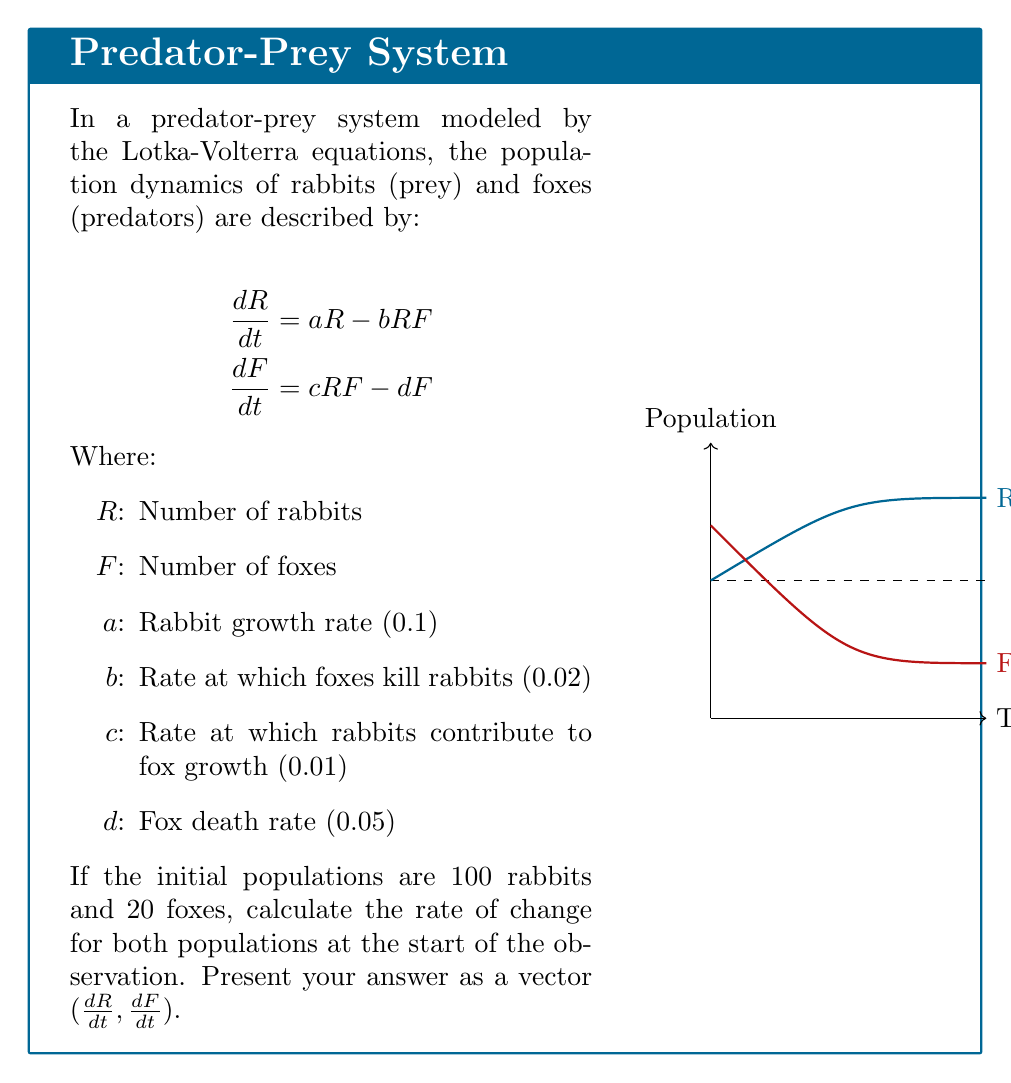Could you help me with this problem? To solve this problem, we'll follow these steps:

1) First, let's identify the given values:
   $R = 100$ (initial rabbit population)
   $F = 20$ (initial fox population)
   $a = 0.1$
   $b = 0.02$
   $c = 0.01$
   $d = 0.05$

2) Now, we'll calculate $dR/dt$ using the first equation:
   $$\frac{dR}{dt} = aR - bRF$$
   $$\frac{dR}{dt} = (0.1 \times 100) - (0.02 \times 100 \times 20)$$
   $$\frac{dR}{dt} = 10 - 40 = -30$$

3) Next, we'll calculate $dF/dt$ using the second equation:
   $$\frac{dF}{dt} = cRF - dF$$
   $$\frac{dF}{dt} = (0.01 \times 100 \times 20) - (0.05 \times 20)$$
   $$\frac{dF}{dt} = 20 - 1 = 19$$

4) Finally, we combine these results into a vector:
   $(\frac{dR}{dt}, \frac{dF}{dt}) = (-30, 19)$

This vector represents the instantaneous rate of change for both populations at the start of the observation.
Answer: $(-30, 19)$ 